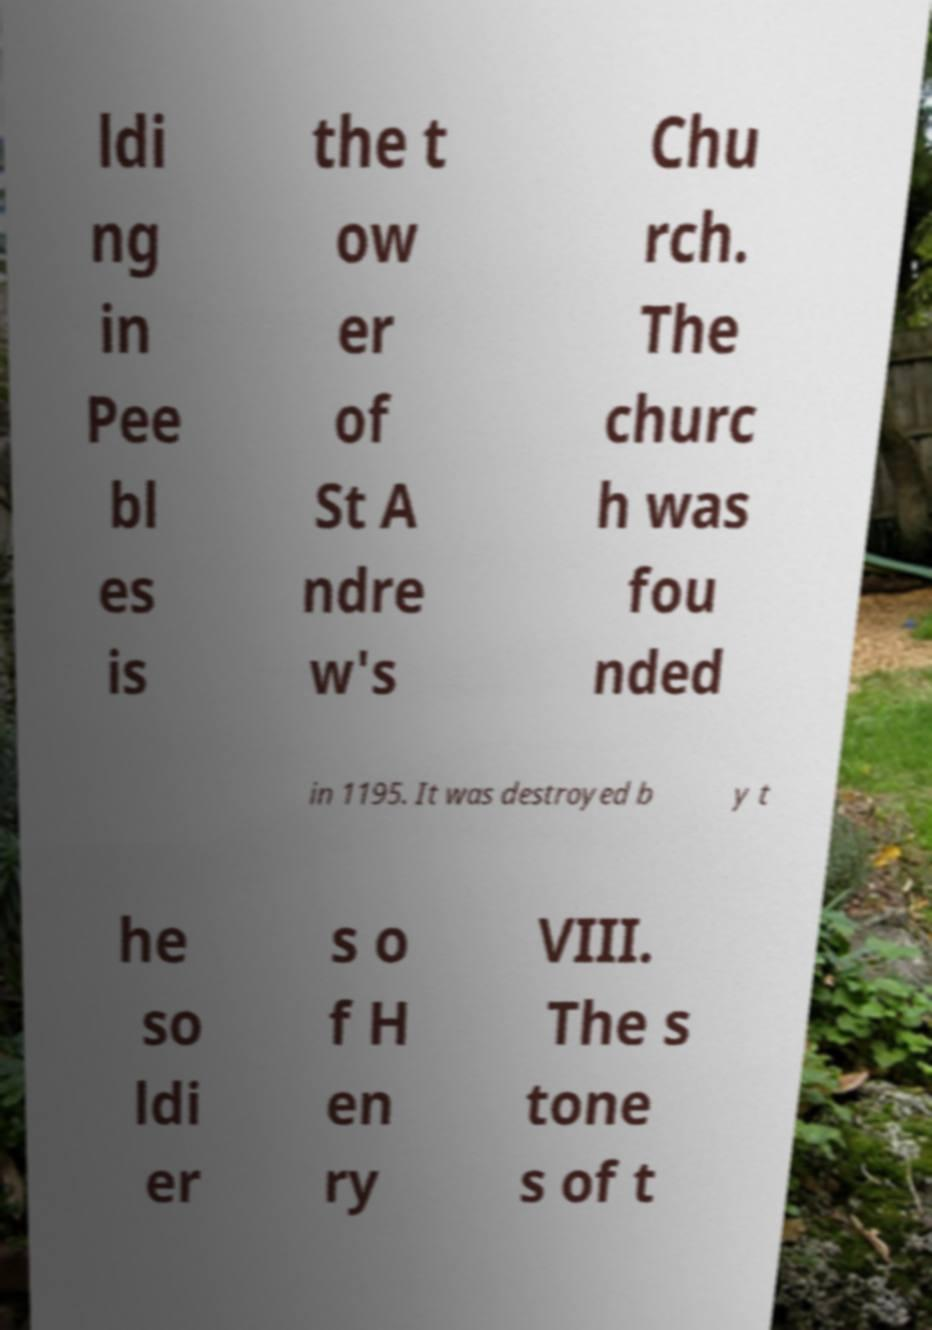Please read and relay the text visible in this image. What does it say? ldi ng in Pee bl es is the t ow er of St A ndre w's Chu rch. The churc h was fou nded in 1195. It was destroyed b y t he so ldi er s o f H en ry VIII. The s tone s of t 